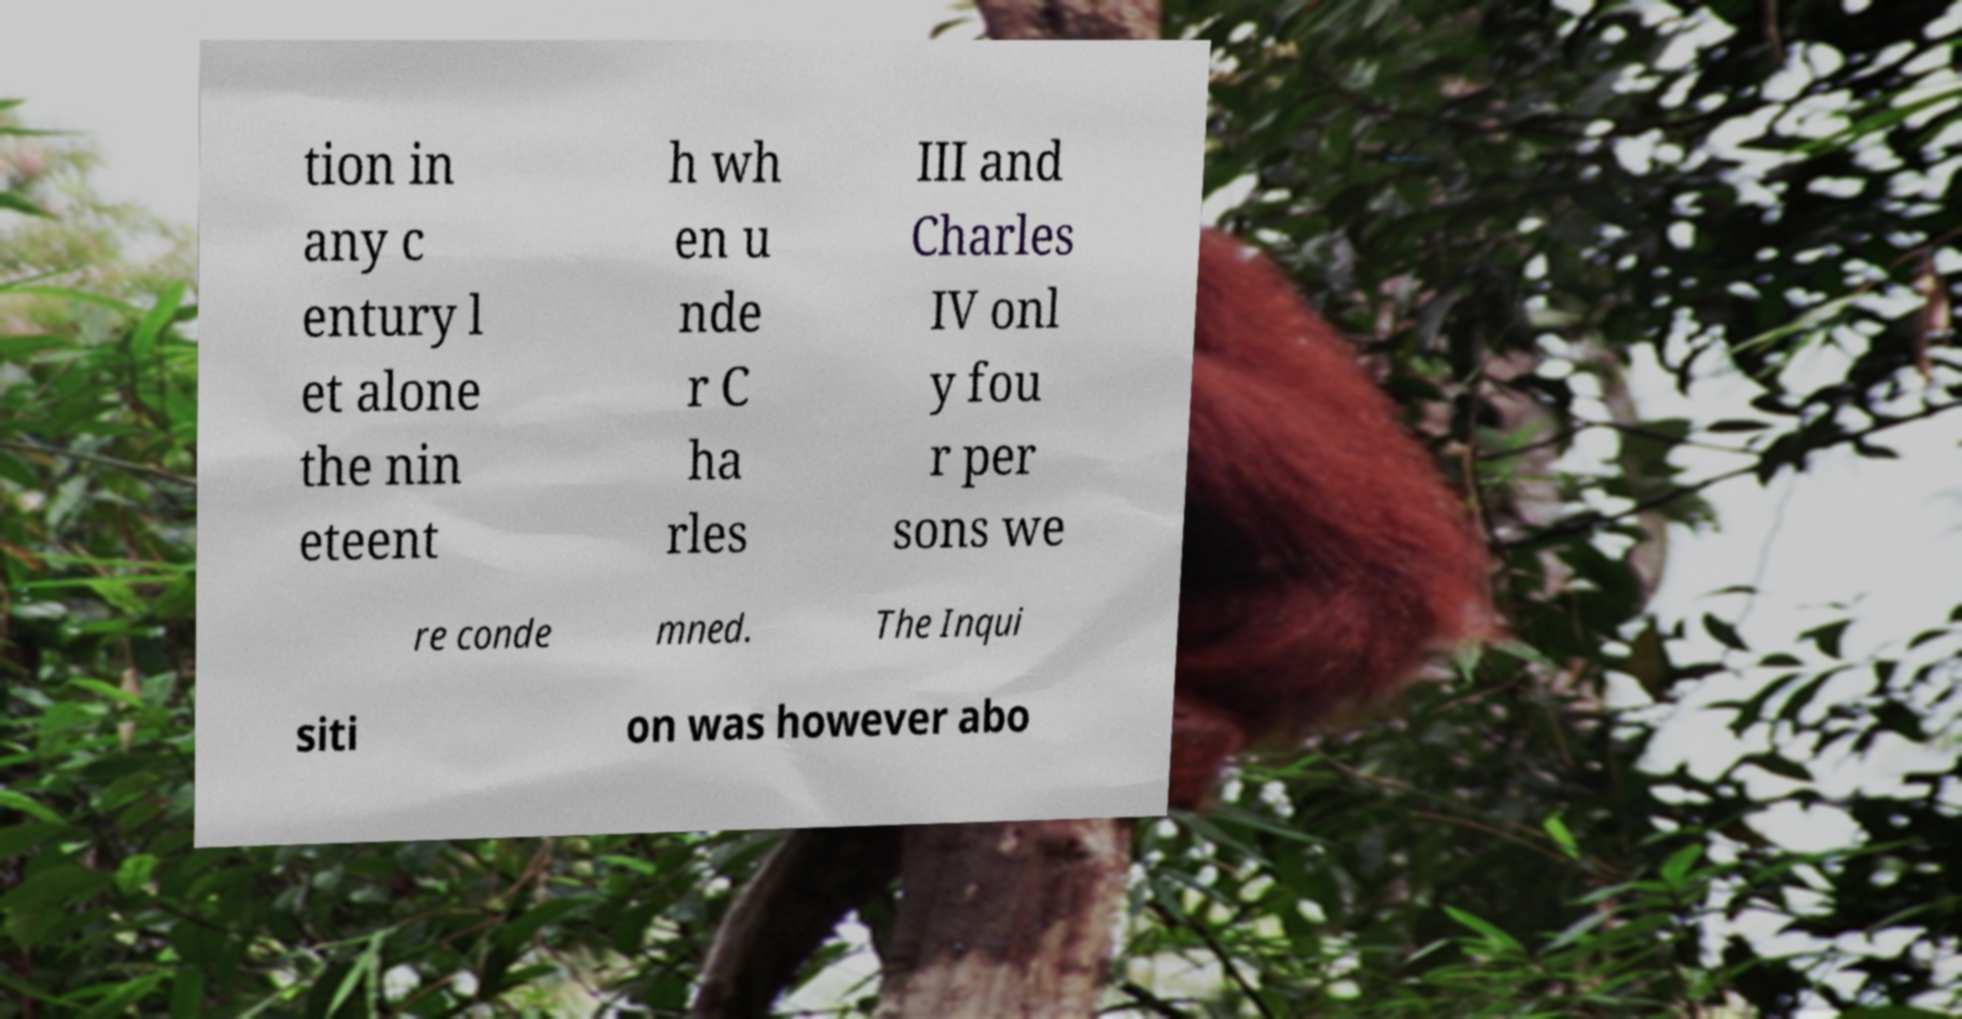Could you extract and type out the text from this image? tion in any c entury l et alone the nin eteent h wh en u nde r C ha rles III and Charles IV onl y fou r per sons we re conde mned. The Inqui siti on was however abo 